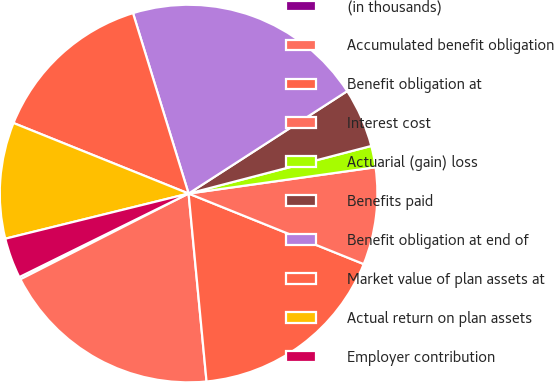Convert chart. <chart><loc_0><loc_0><loc_500><loc_500><pie_chart><fcel>(in thousands)<fcel>Accumulated benefit obligation<fcel>Benefit obligation at<fcel>Interest cost<fcel>Actuarial (gain) loss<fcel>Benefits paid<fcel>Benefit obligation at end of<fcel>Market value of plan assets at<fcel>Actual return on plan assets<fcel>Employer contribution<nl><fcel>0.21%<fcel>19.01%<fcel>17.39%<fcel>8.32%<fcel>1.83%<fcel>5.07%<fcel>20.63%<fcel>14.15%<fcel>9.94%<fcel>3.45%<nl></chart> 